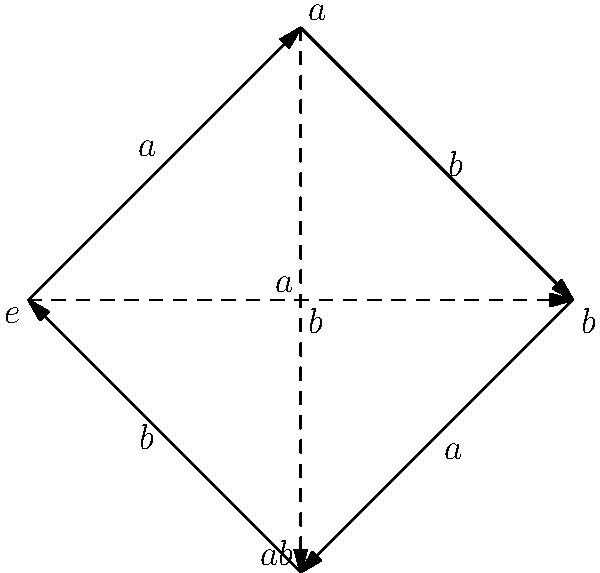Consider the Cayley graph of a finite group representing packet routing in an IoT network, as shown above. The graph has four nodes labeled $e$, $a$, $b$, and $ab$, with solid arrows representing generator $a$ and dashed arrows representing generator $b$. What is the order of element $a$ in this group, and how does this relate to the maximum number of hops a data packet might take when routed using only operation $a$? To determine the order of element $a$ and its relationship to packet routing, we'll follow these steps:

1. Recall that the order of an element in a group is the smallest positive integer $n$ such that $a^n = e$, where $e$ is the identity element.

2. Trace the path in the Cayley graph starting from $e$ and following only the solid arrows (representing $a$):
   $e \xrightarrow{a} a \xrightarrow{a} b \xrightarrow{a} ab \xrightarrow{a} e$

3. We see that it takes 4 applications of $a$ to return to the identity element $e$. Therefore, the order of $a$ is 4.

4. In terms of packet routing:
   - Each application of $a$ corresponds to one hop in the network.
   - The order of $a$ (4) represents a complete cycle through all nodes.
   - This means a packet routed using only operation $a$ will visit all nodes before returning to its starting point.

5. The maximum number of hops a packet might take when routed using only operation $a$ is equal to the order of $a$ minus 1:
   Maximum hops = Order of $a$ - 1 = 4 - 1 = 3

This is because the packet reaches every other node in at most 3 hops before potentially returning to its origin on the 4th hop.
Answer: Order of $a$ is 4; maximum hops using $a$ is 3. 